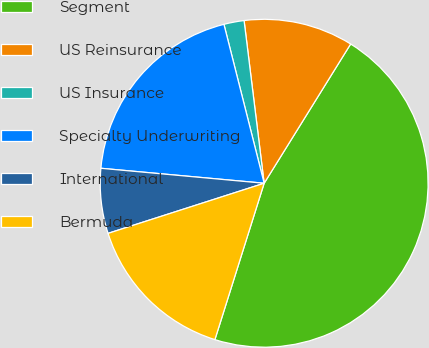<chart> <loc_0><loc_0><loc_500><loc_500><pie_chart><fcel>Segment<fcel>US Reinsurance<fcel>US Insurance<fcel>Specialty Underwriting<fcel>International<fcel>Bermuda<nl><fcel>46.01%<fcel>10.8%<fcel>1.99%<fcel>19.6%<fcel>6.4%<fcel>15.2%<nl></chart> 